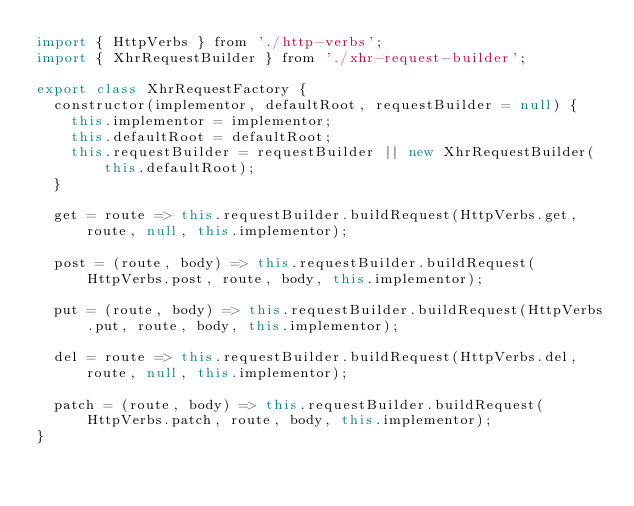<code> <loc_0><loc_0><loc_500><loc_500><_JavaScript_>import { HttpVerbs } from './http-verbs';
import { XhrRequestBuilder } from './xhr-request-builder';

export class XhrRequestFactory {
  constructor(implementor, defaultRoot, requestBuilder = null) {
    this.implementor = implementor;
    this.defaultRoot = defaultRoot;
    this.requestBuilder = requestBuilder || new XhrRequestBuilder(this.defaultRoot);
  }

  get = route => this.requestBuilder.buildRequest(HttpVerbs.get, route, null, this.implementor);

  post = (route, body) => this.requestBuilder.buildRequest(HttpVerbs.post, route, body, this.implementor);

  put = (route, body) => this.requestBuilder.buildRequest(HttpVerbs.put, route, body, this.implementor);

  del = route => this.requestBuilder.buildRequest(HttpVerbs.del, route, null, this.implementor);

  patch = (route, body) => this.requestBuilder.buildRequest(HttpVerbs.patch, route, body, this.implementor);
}
</code> 